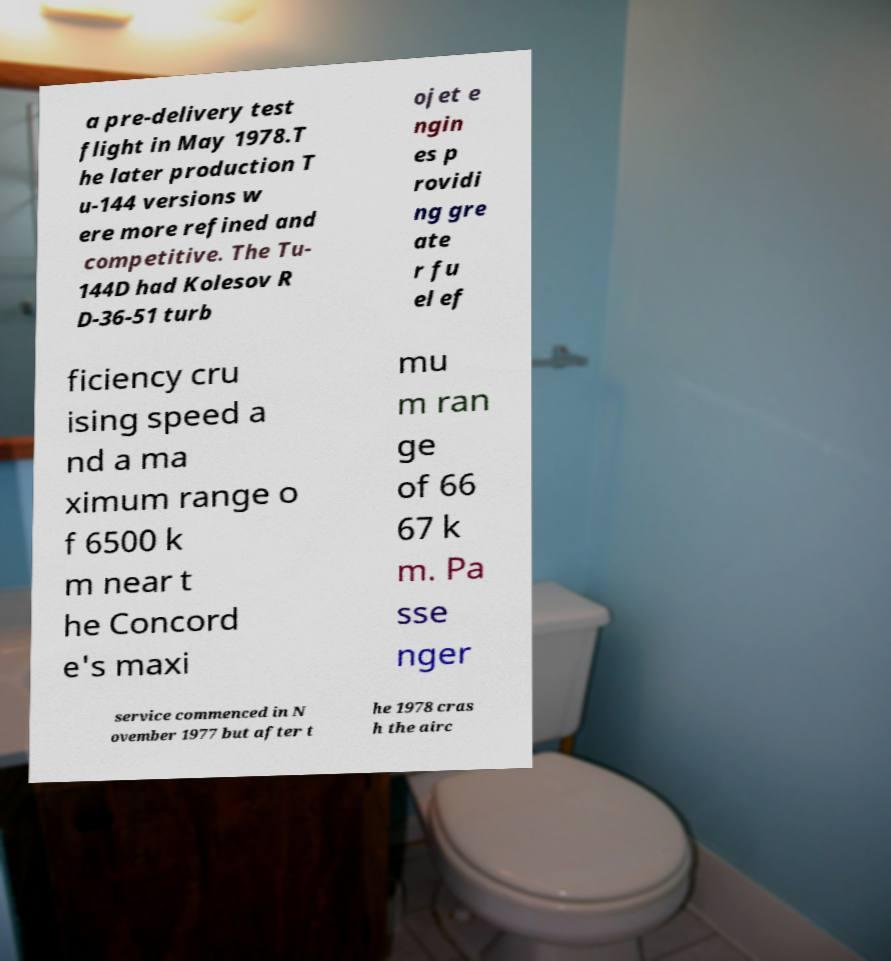Could you assist in decoding the text presented in this image and type it out clearly? a pre-delivery test flight in May 1978.T he later production T u-144 versions w ere more refined and competitive. The Tu- 144D had Kolesov R D-36-51 turb ojet e ngin es p rovidi ng gre ate r fu el ef ficiency cru ising speed a nd a ma ximum range o f 6500 k m near t he Concord e's maxi mu m ran ge of 66 67 k m. Pa sse nger service commenced in N ovember 1977 but after t he 1978 cras h the airc 